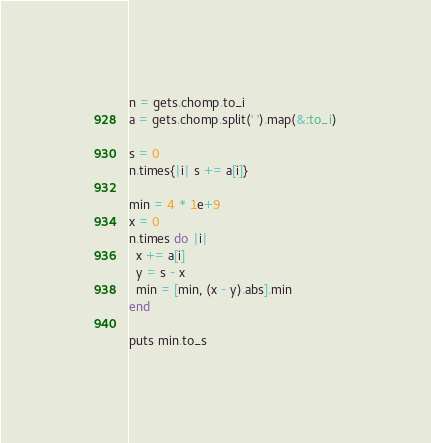Convert code to text. <code><loc_0><loc_0><loc_500><loc_500><_Ruby_>n = gets.chomp.to_i
a = gets.chomp.split(' ').map(&:to_i)

s = 0
n.times{|i| s += a[i]}

min = 4 * 1e+9
x = 0
n.times do |i|
  x += a[i]
  y = s - x
  min = [min, (x - y).abs].min
end

puts min.to_s</code> 